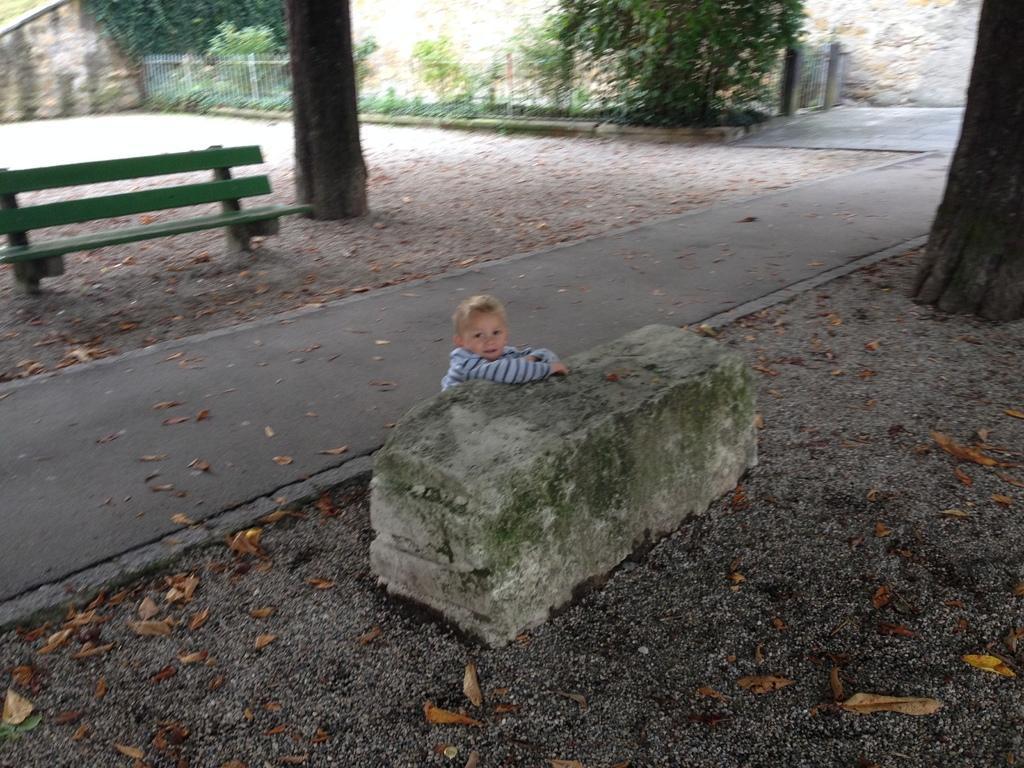How would you summarize this image in a sentence or two? there is a stone. behind that there is a person laying. behind the person there is a walk way. behind the walk way. behind that there is a bench and trees. behind trees there is fencing and other trees. 